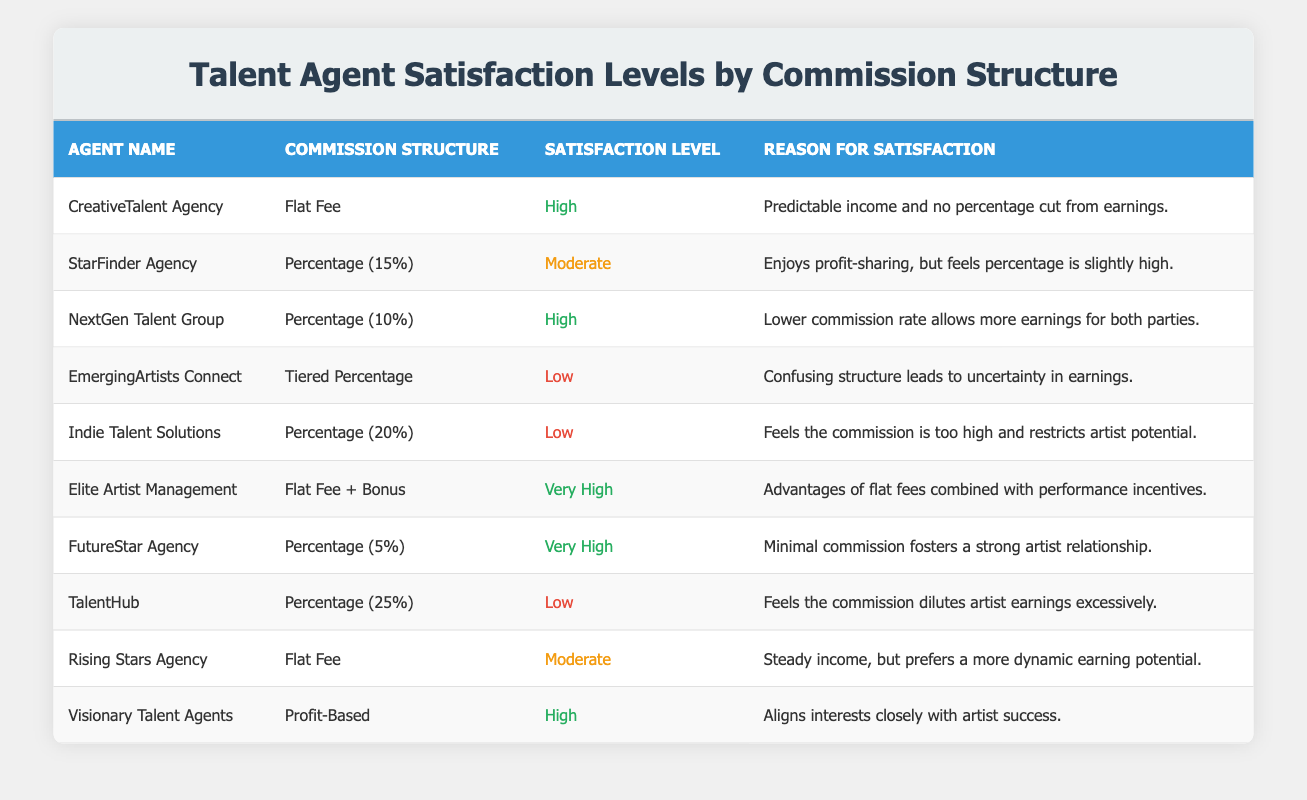What is the satisfaction level of CreativeTalent Agency? The table shows the satisfaction level for CreativeTalent Agency is categorized as "High." This is easily found in the row corresponding to the agency's name.
Answer: High Which commission structure has the highest satisfaction level? By examining the satisfaction levels, we see that "Very High" is the highest category. There are two agencies with a "Very High" satisfaction level: "Elite Artist Management" and "FutureStar Agency," both of which employ different commission structures (Flat Fee + Bonus and Percentage (5%) respectively).
Answer: Flat Fee + Bonus and Percentage (5%) How many agencies have a "Low" satisfaction level? Upon inspecting the table, three agencies are listed with a "Low" satisfaction level: "EmergingArtists Connect," "Indie Talent Solutions," and "TalentHub." Hence, the total count is three.
Answer: 3 Does every agency with a "Flat Fee" commission structure have a "High" satisfaction level? From the table, there are two agencies with a "Flat Fee" commission structure: "CreativeTalent Agency" has a "High" satisfaction level, while "Rising Stars Agency" has a "Moderate" satisfaction level. Therefore, not all agencies with a "Flat Fee" structure have a "High" satisfaction.
Answer: No What is the average commission percentage for agencies with "Moderate" or lower satisfaction levels? Filtering the satisfaction levels shows that "StarFinder Agency" (15%), "EmergingArtists Connect" (Tiered Percentage), "Indie Talent Solutions" (20%), "TalentHub" (25%), and "Rising Stars Agency" (Flat Fee). To find the average, we can denote Tiered Percentage as uncertain or treat it as 0%. Thus, we average (15 + 20 + 25 + 0) / 4 = 15.
Answer: 15 How does the satisfaction level correlate with the commission structures? By reviewing the table, we see that the satisfaction levels vary with commission structures. Agencies with lower percentages tend to have higher satisfaction levels, whereas those with higher commission percentages (like 20% and 25%) tend to report lower satisfaction levels. This indicates a possible negative correlation between commission rates and satisfaction levels.
Answer: Negative correlation What is the reason for the satisfaction level of "Visionary Talent Agents"? According to the table, "Visionary Talent Agents" has a "High" satisfaction level because they align their interests closely with artist success. The reason is found in the corresponding row of the table.
Answer: Aligns interests closely with artist success Which commission structure had the highest number of agencies with "Very High" satisfaction levels? The table lists only two commission structures with agencies assigned "Very High" satisfaction levels: Flat Fee + Bonus and Percentage (5%). Each has one agency, making it equal in count.
Answer: Each has one agency 